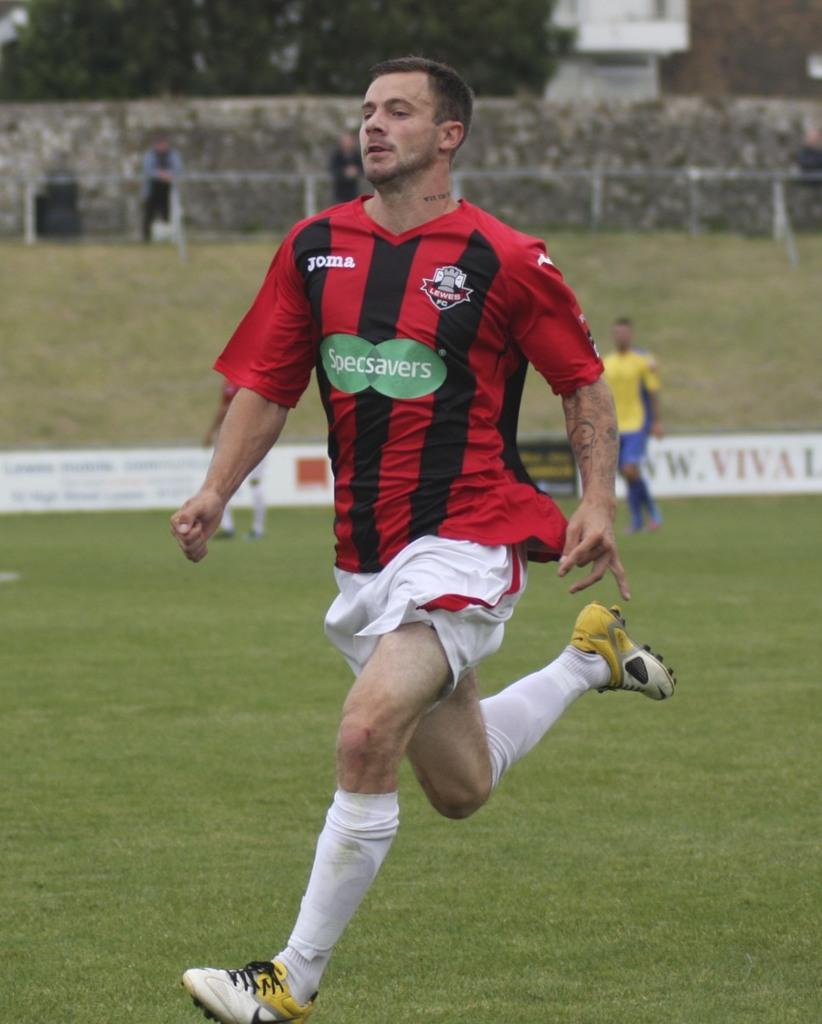What is the person in the image doing? The person is running in the image. What color combination is featured on the dress the person is wearing? The dress has red, black, and white colors. Can you describe the background of the image? There are people visible in the background, along with trees and a building. What type of structure can be seen in the image? There is fencing in the image. What is the title of the fiction book the person is holding while running? There is no book present in the image, and the person is not holding anything while running. 